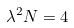Convert formula to latex. <formula><loc_0><loc_0><loc_500><loc_500>\lambda ^ { 2 } N = 4</formula> 